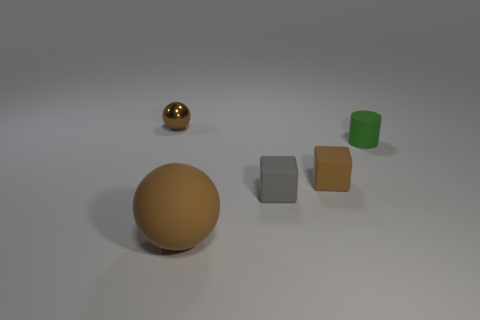Add 2 large yellow matte cylinders. How many objects exist? 7 Subtract all spheres. How many objects are left? 3 Add 4 brown cubes. How many brown cubes exist? 5 Subtract 0 purple balls. How many objects are left? 5 Subtract all brown blocks. Subtract all tiny objects. How many objects are left? 0 Add 5 brown rubber blocks. How many brown rubber blocks are left? 6 